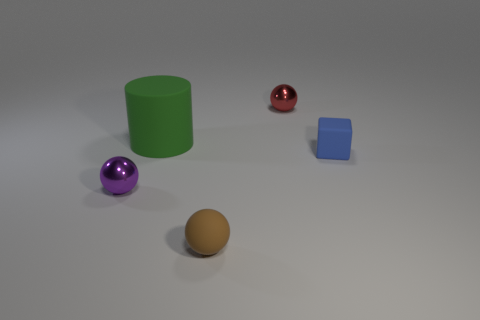Are there any other things that are the same size as the cylinder?
Ensure brevity in your answer.  No. Are the object on the left side of the large cylinder and the sphere behind the cube made of the same material?
Make the answer very short. Yes. How many objects are big green things or spheres that are in front of the blue object?
Ensure brevity in your answer.  3. Are there any other things that are the same material as the large thing?
Provide a succinct answer. Yes. What is the small blue block made of?
Your answer should be compact. Rubber. Does the red thing have the same material as the big green thing?
Provide a succinct answer. No. How many matte objects are either green cylinders or small brown cylinders?
Offer a terse response. 1. What shape is the red shiny object that is behind the tiny blue block?
Provide a short and direct response. Sphere. There is a green cylinder that is the same material as the small brown sphere; what is its size?
Ensure brevity in your answer.  Large. The small thing that is both behind the tiny purple metallic sphere and in front of the red shiny ball has what shape?
Offer a terse response. Cube. 